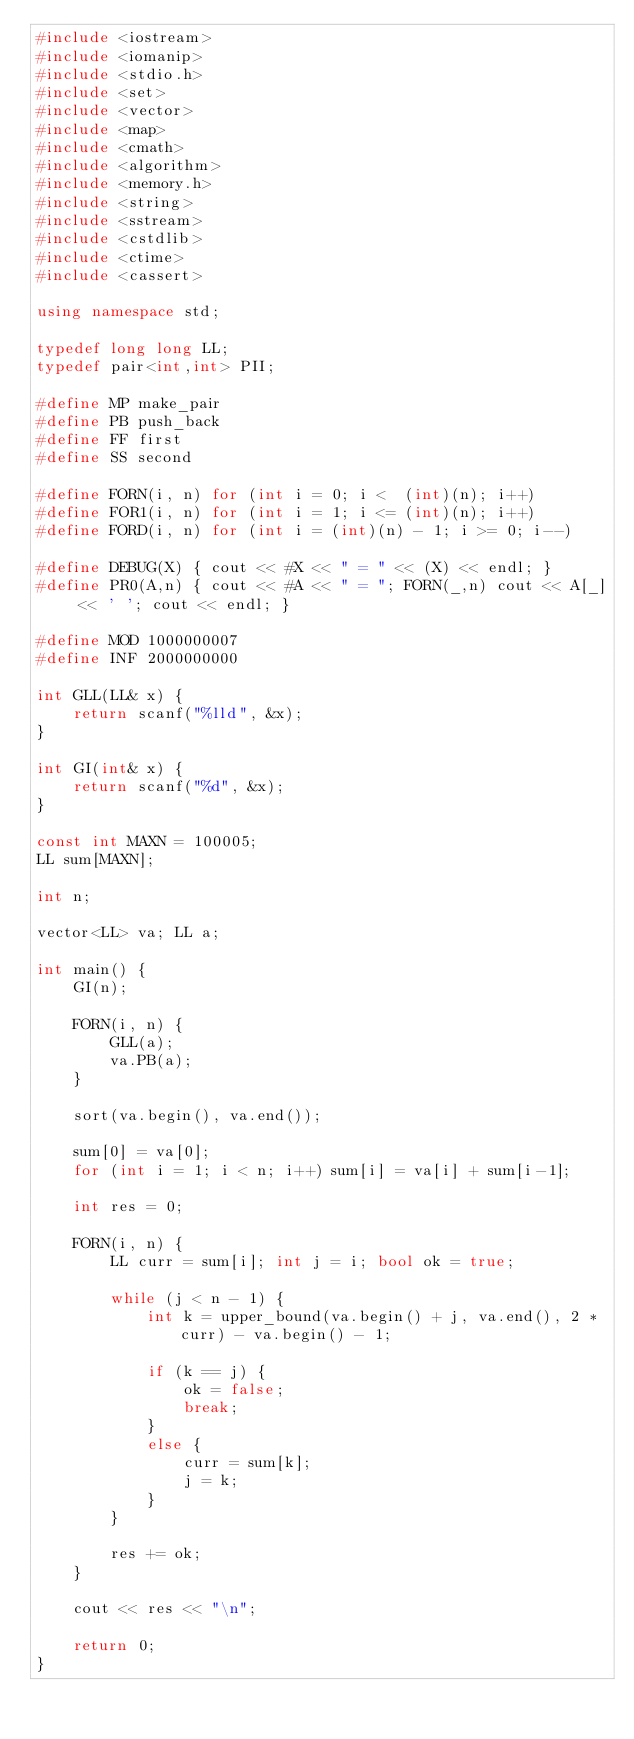<code> <loc_0><loc_0><loc_500><loc_500><_C++_>#include <iostream>
#include <iomanip>
#include <stdio.h>
#include <set>
#include <vector>
#include <map>
#include <cmath>
#include <algorithm>
#include <memory.h>
#include <string>
#include <sstream>
#include <cstdlib>
#include <ctime>
#include <cassert>

using namespace std;

typedef long long LL;
typedef pair<int,int> PII;

#define MP make_pair
#define PB push_back
#define FF first
#define SS second

#define FORN(i, n) for (int i = 0; i <  (int)(n); i++)
#define FOR1(i, n) for (int i = 1; i <= (int)(n); i++)
#define FORD(i, n) for (int i = (int)(n) - 1; i >= 0; i--)

#define DEBUG(X) { cout << #X << " = " << (X) << endl; }
#define PR0(A,n) { cout << #A << " = "; FORN(_,n) cout << A[_] << ' '; cout << endl; }

#define MOD 1000000007
#define INF 2000000000

int GLL(LL& x) {
    return scanf("%lld", &x);
}

int GI(int& x) {
    return scanf("%d", &x);
}

const int MAXN = 100005;
LL sum[MAXN];

int n;

vector<LL> va; LL a;

int main() {
    GI(n);

    FORN(i, n) {
        GLL(a);
        va.PB(a);
    }

    sort(va.begin(), va.end());

    sum[0] = va[0];
    for (int i = 1; i < n; i++) sum[i] = va[i] + sum[i-1];

    int res = 0;

    FORN(i, n) {
        LL curr = sum[i]; int j = i; bool ok = true;

        while (j < n - 1) {
            int k = upper_bound(va.begin() + j, va.end(), 2 * curr) - va.begin() - 1;
            
            if (k == j) {
                ok = false;
                break;
            }
            else {
                curr = sum[k];
                j = k;
            }
        }

        res += ok;
    }

    cout << res << "\n";
    
    return 0;
}</code> 